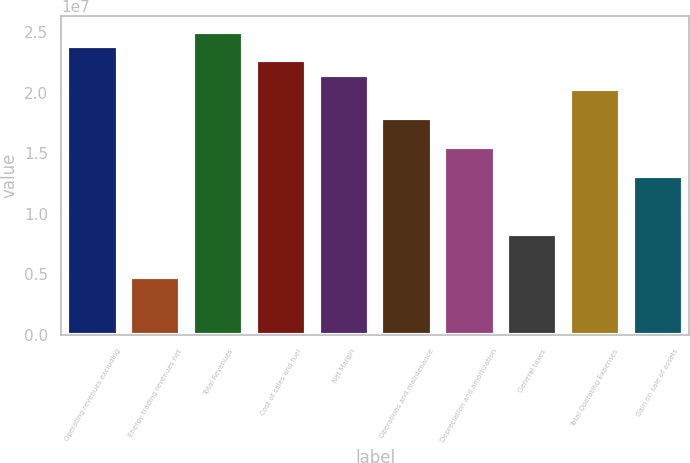Convert chart. <chart><loc_0><loc_0><loc_500><loc_500><bar_chart><fcel>Operating revenues excluding<fcel>Energy trading revenues net<fcel>Total Revenues<fcel>Cost of sales and fuel<fcel>Net Margin<fcel>Operations and maintenance<fcel>Depreciation and amortization<fcel>General taxes<fcel>Total Operating Expenses<fcel>Gain on sale of assets<nl><fcel>2.38407e+07<fcel>4.76813e+06<fcel>2.50327e+07<fcel>2.26486e+07<fcel>2.14566e+07<fcel>1.78805e+07<fcel>1.54964e+07<fcel>8.34423e+06<fcel>2.02646e+07<fcel>1.31124e+07<nl></chart> 